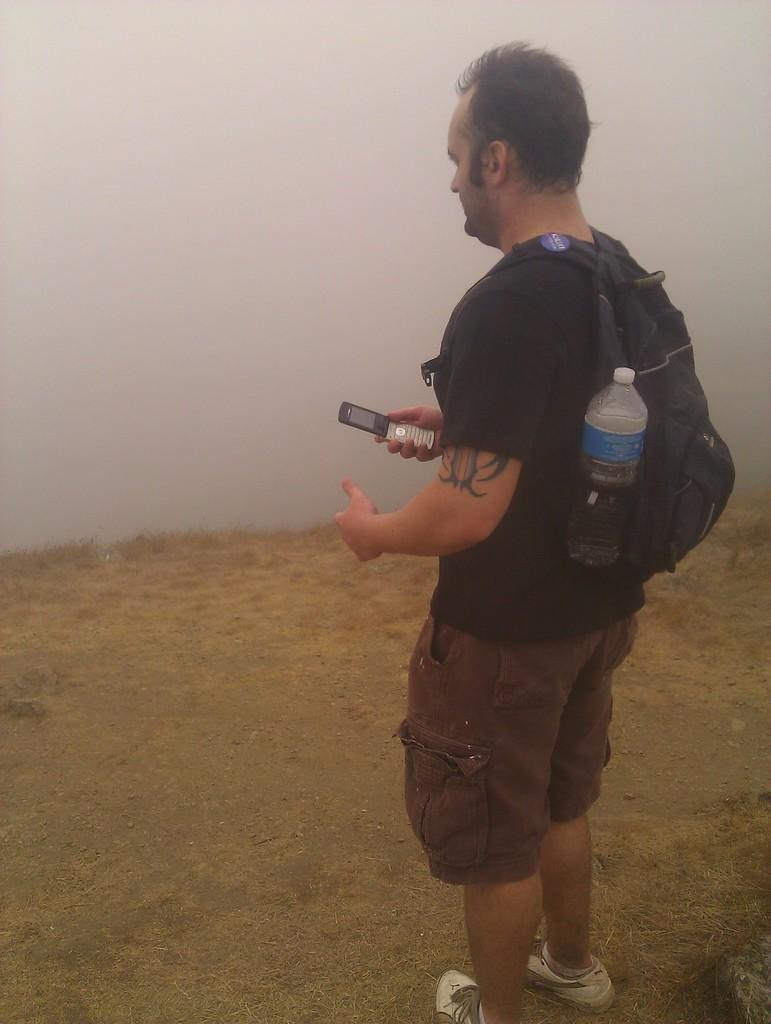Who is present in the image? There is a man in the image. What is the man wearing? The man is wearing a black t-shirt. What is the man carrying in the image? The man is carrying a bag with a bottle. What is the man holding in the image? The man is holding a mobile phone. What type of grip does the man have on the volleyball in the image? There is no volleyball present in the image, so it is not possible to determine the type of grip the man has on it. 